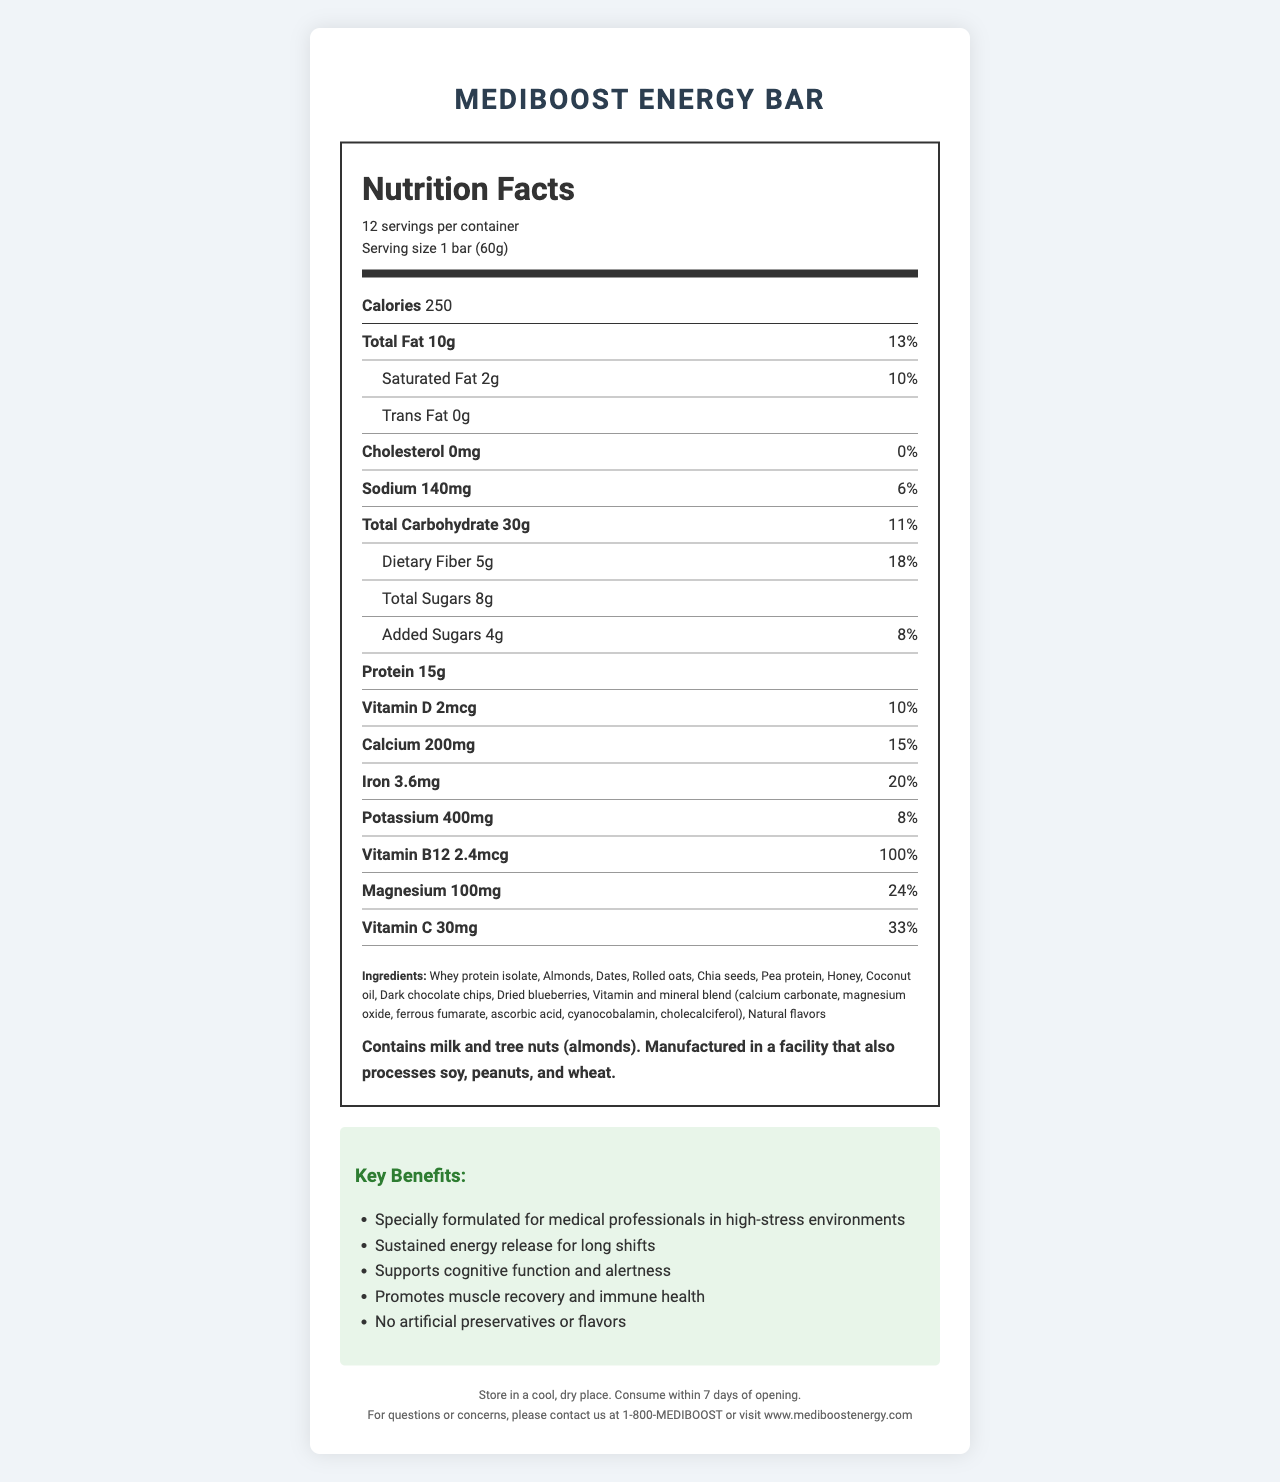how many servings are in a container? The container has 12 servings as mentioned under "12 servings per container" in the serving info section.
Answer: 12 servings what is the serving size? The serving size is specified as "1 bar (60g)" in the nutrition label.
Answer: 1 bar (60g) how many calories are in one serving? The nutrition label states that one serving contains 250 calories under the "Calories" section.
Answer: 250 calories what is the amount of protein per serving? The document lists the amount of protein per serving as 15g in the nutrition label.
Answer: 15g how much dietary fiber does one energy bar contain? The nutrient row for dietary fiber shows that there are 5g of dietary fiber per serving.
Answer: 5g how much sodium is in one serving? According to the nutrition label, one serving contains 140mg of sodium.
Answer: 140mg what kind of allergens are present in this energy bar? The allergen information states that the bar contains milk and tree nuts (almonds).
Answer: Contains milk and tree nuts (almonds) what percentage of the daily value for iron does one bar provide? The nutrient row for iron indicates that one serving provides 20% of the daily value.
Answer: 20% which of the following is not a key benefit claimed by MediBoost Energy Bar? A. Supports mental health B. Sustained energy release for long shifts C. Supports cognitive function and alertness D. Promotes muscle recovery and immune health The document lists "Sustained energy release for long shifts", "Supports cognitive function and alertness", and "Promotes muscle recovery and immune health" but does not mention anything about supporting mental health.
Answer: A which ingredient is not in MediBoost Energy Bar? I. Dates II. Banana III. Almonds IV. Whey protein isolate The ingredient list includes dates, almonds, and whey protein isolate but not bananas.
Answer: II. Banana are there any artificial preservatives in the MediBoost Energy Bar? The marketing claims mention "No artificial preservatives or flavors".
Answer: No describe the main purpose of the MediBoost Energy Bar The document highlights that the energy bar is specially formulated for medical professionals, offers sustained energy release, supports cognitive function and alertness, and promotes muscle recovery and immune health. The bar also avoids artificial preservatives and flavors.
Answer: The MediBoost Energy Bar is designed to provide medical professionals with sustained energy, cognitive support, and nutritional benefits suitable for high-stress environments like long shifts. It aims to support muscle recovery, immune health, and overall alertness without using artificial preservatives or flavors. which vitamin provides the highest percentage of the daily value in one energy bar? Vitamin B12 provides 100% of the daily value, which is the highest among the listed vitamins and minerals.
Answer: Vitamin B12 what is the storage recommendation for the MediBoost Energy Bar? The storage instructions recommend keeping the bar in a cool, dry place and consuming it within 7 days of opening.
Answer: Store in a cool, dry place. Consume within 7 days of opening. how many grams of total carbohydrates are there in one bar? According to the nutrition label, one serving contains 30g of total carbohydrates.
Answer: 30g what is the contact number for questions or concerns? The contact information section lists the number as 1-800-MEDIBOOST.
Answer: 1-800-MEDIBOOST what is the percentage of daily value for potassium provided by one bar? The nutrient row for potassium indicates that one serving provides 8% of the daily value.
Answer: 8% how much total sugar does one energy bar contain? The nutrition label specifies that there are 8g of total sugars in one serving.
Answer: 8g how much added sugar does one energy bar have? The nutrient row for added sugars shows that there are 4g of added sugars per serving.
Answer: 4g can we determine the price of the MediBoost Energy Bar from the document? The document does not provide any information regarding the price of the energy bar.
Answer: Cannot be determined 